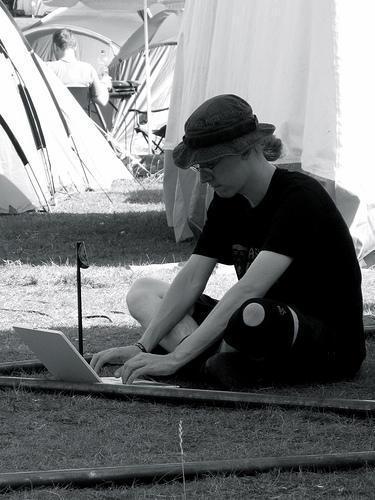How many people are there?
Give a very brief answer. 2. 